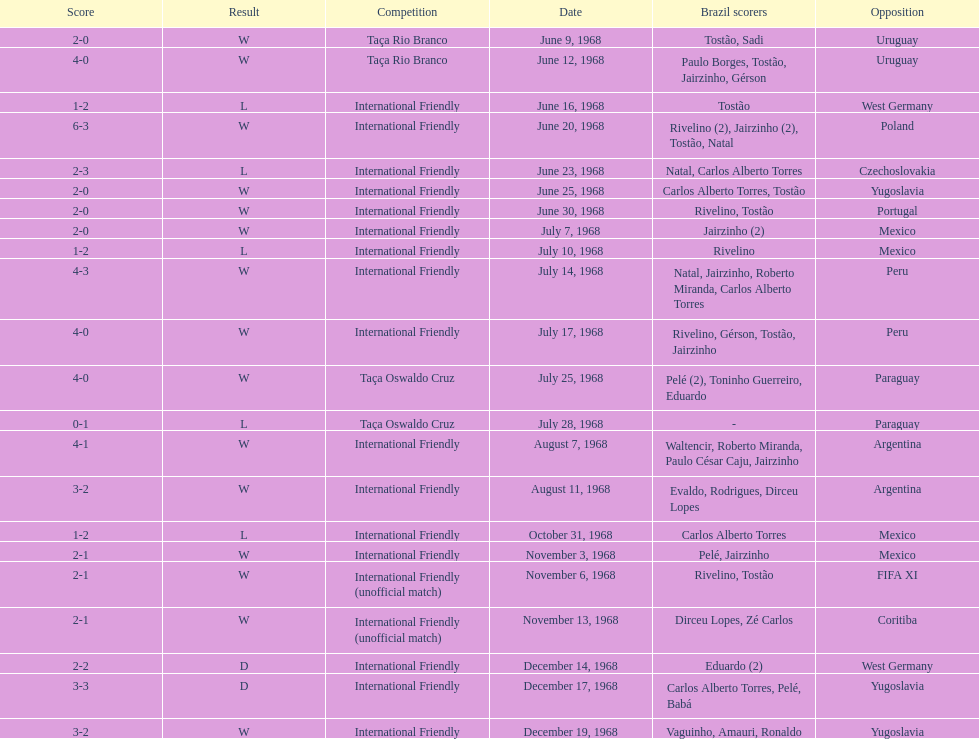How many times did brazil score during the game on november 6th? 2. 